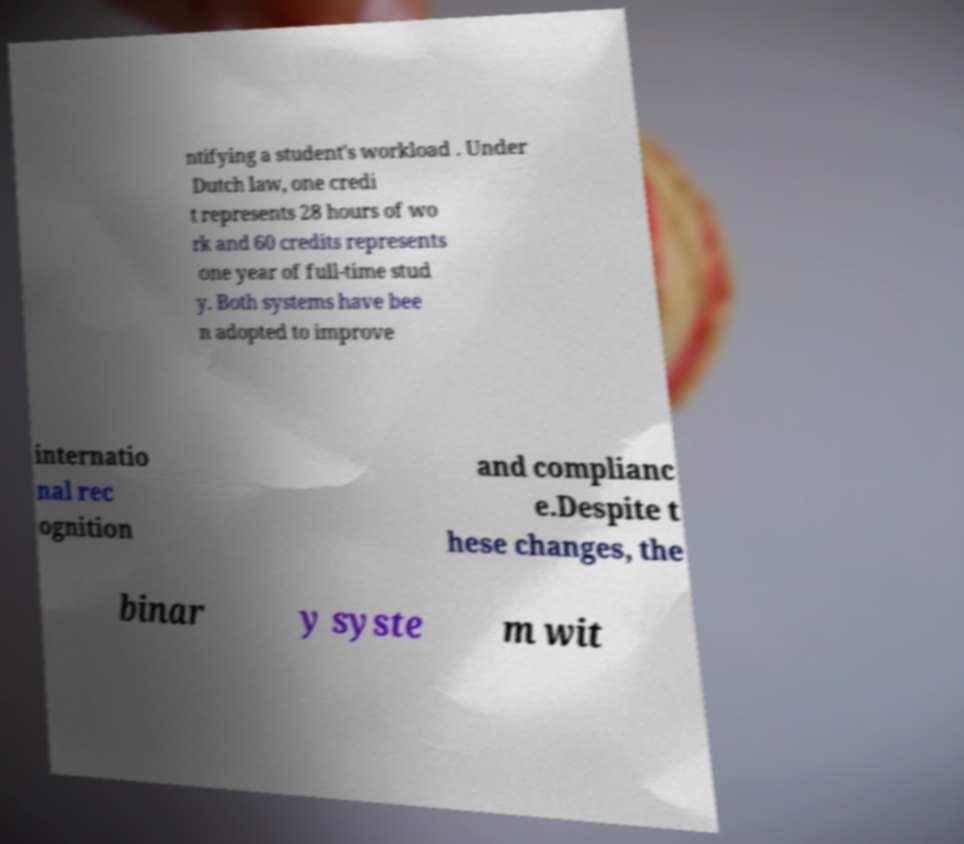What messages or text are displayed in this image? I need them in a readable, typed format. ntifying a student's workload . Under Dutch law, one credi t represents 28 hours of wo rk and 60 credits represents one year of full-time stud y. Both systems have bee n adopted to improve internatio nal rec ognition and complianc e.Despite t hese changes, the binar y syste m wit 